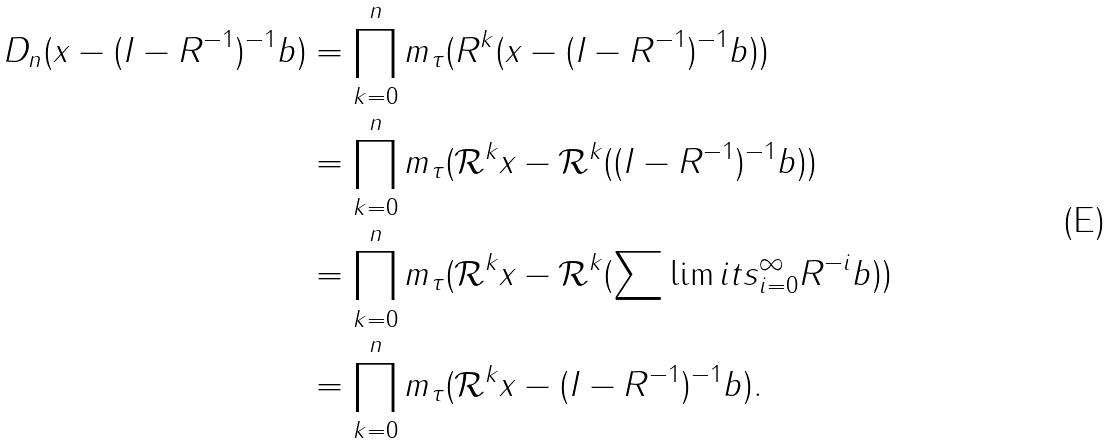Convert formula to latex. <formula><loc_0><loc_0><loc_500><loc_500>D _ { n } ( x - ( I - R ^ { - 1 } ) ^ { - 1 } b ) & = \prod _ { k = 0 } ^ { n } m _ { \tau } ( R ^ { k } ( x - ( I - R ^ { - 1 } ) ^ { - 1 } b ) ) \\ & = \prod _ { k = 0 } ^ { n } m _ { \tau } ( \mathcal { R } ^ { k } x - \mathcal { R } ^ { k } ( ( I - R ^ { - 1 } ) ^ { - 1 } b ) ) \\ & = \prod _ { k = 0 } ^ { n } m _ { \tau } ( \mathcal { R } ^ { k } x - \mathcal { R } ^ { k } ( \sum \lim i t s _ { i = 0 } ^ { \infty } R ^ { - i } b ) ) \\ & = \prod _ { k = 0 } ^ { n } m _ { \tau } ( \mathcal { R } ^ { k } x - ( I - R ^ { - 1 } ) ^ { - 1 } b ) .</formula> 